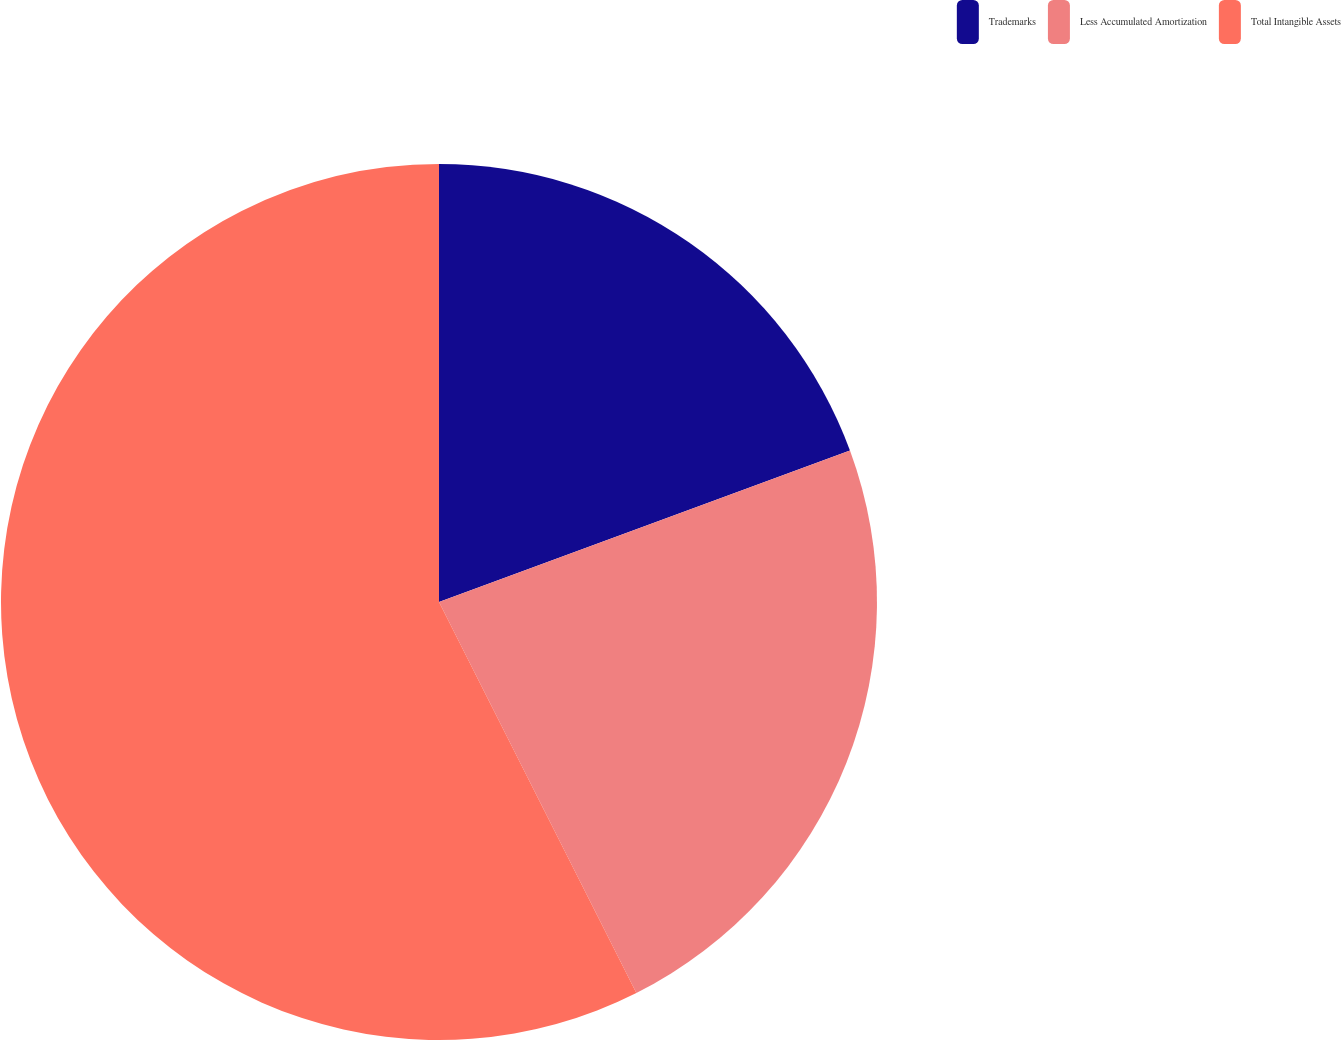<chart> <loc_0><loc_0><loc_500><loc_500><pie_chart><fcel>Trademarks<fcel>Less Accumulated Amortization<fcel>Total Intangible Assets<nl><fcel>19.38%<fcel>23.18%<fcel>57.44%<nl></chart> 